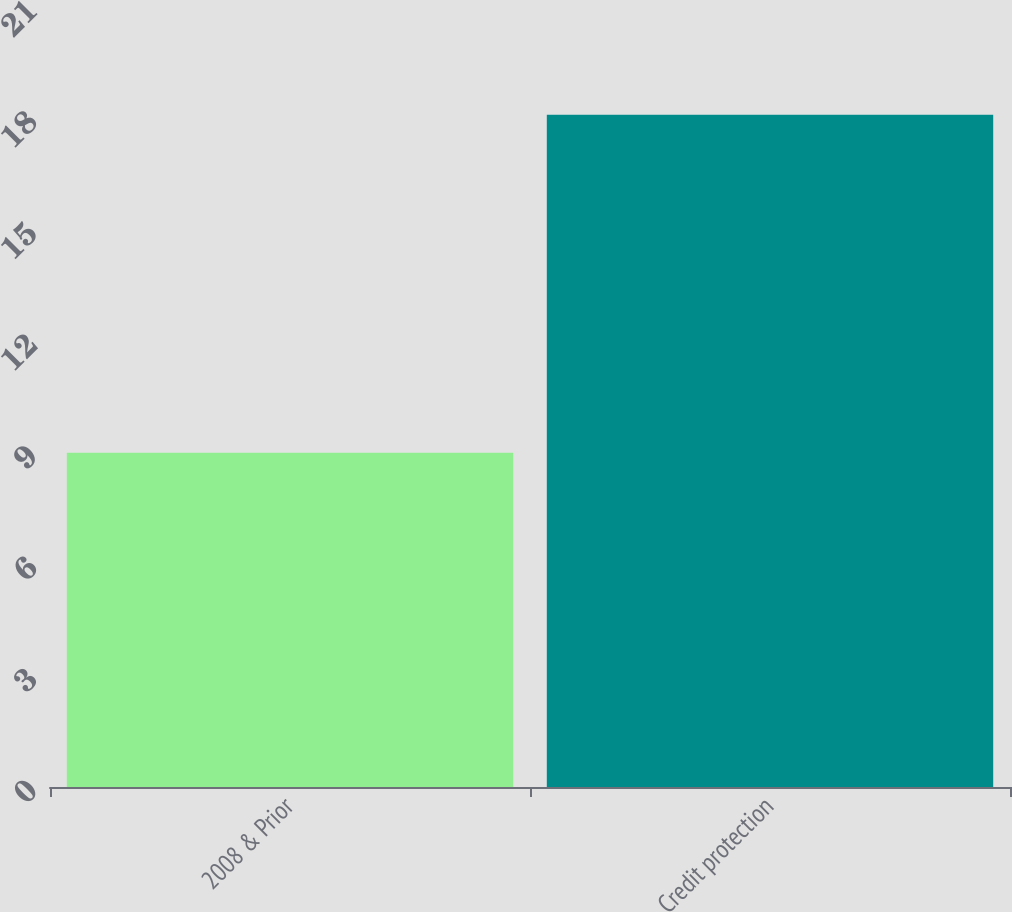<chart> <loc_0><loc_0><loc_500><loc_500><bar_chart><fcel>2008 & Prior<fcel>Credit protection<nl><fcel>9<fcel>18.1<nl></chart> 